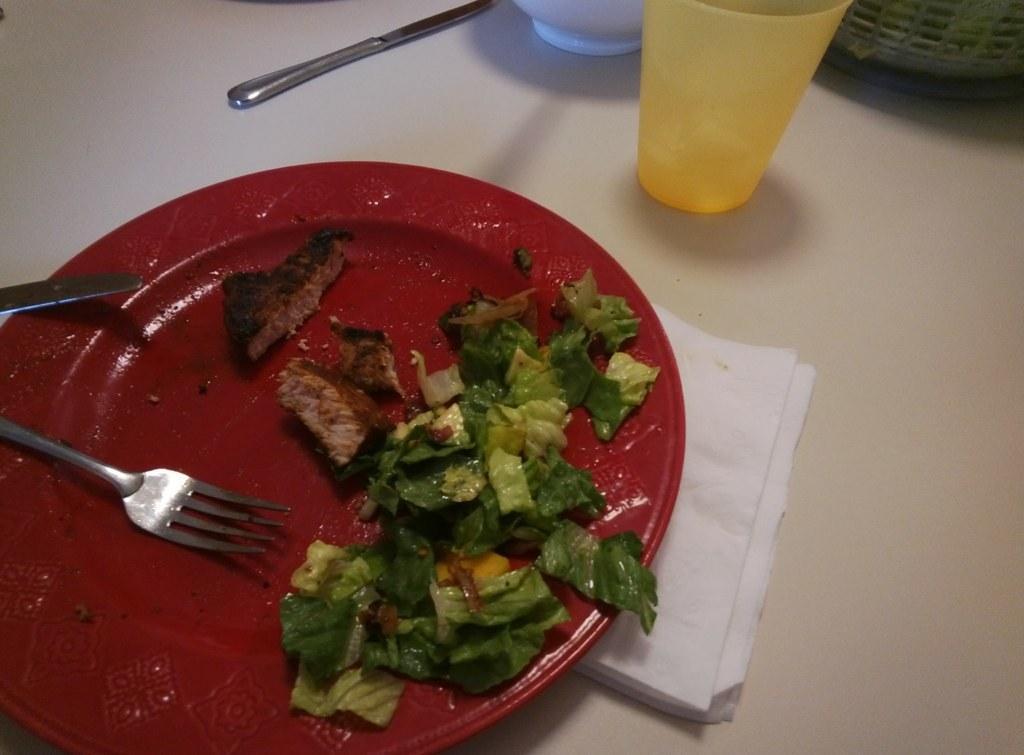How would you summarize this image in a sentence or two? In this image I can see a red color plate , on the plate I can see a food item and fork and under the plate I can see tissue paper kept on the table ,at the top I can see glass, white color bowl and green color bowl and spoon. 